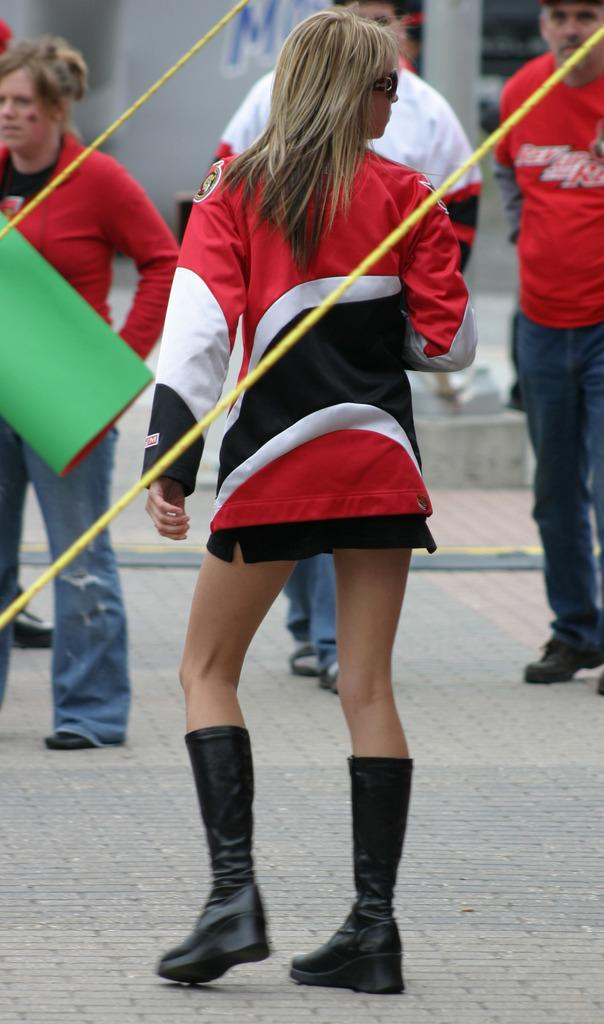How many people are in the image? There is a group of people in the image, but the exact number is not specified. What are the people doing in the image? The people are standing on the ground in the image. What can be seen in addition to the people in the image? There is a chart and ropes visible in the image. What is written on the wall in the background of the image? There is a wall with text on it in the background of the image, but the specific text is not mentioned. What type of fish can be seen swimming in the chart in the image? There is no fish present in the image, as the chart does not depict any aquatic life. 